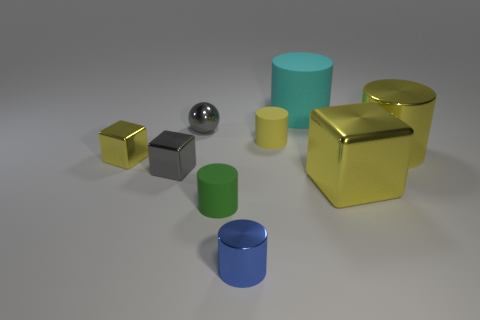Subtract all red cubes. How many yellow cylinders are left? 2 Subtract all shiny cylinders. How many cylinders are left? 3 Subtract 1 cylinders. How many cylinders are left? 4 Subtract all yellow cylinders. How many cylinders are left? 3 Add 1 tiny things. How many objects exist? 10 Subtract all gray cylinders. Subtract all red balls. How many cylinders are left? 5 Subtract all balls. How many objects are left? 8 Add 5 yellow cylinders. How many yellow cylinders exist? 7 Subtract 0 cyan cubes. How many objects are left? 9 Subtract all small metallic spheres. Subtract all big yellow shiny blocks. How many objects are left? 7 